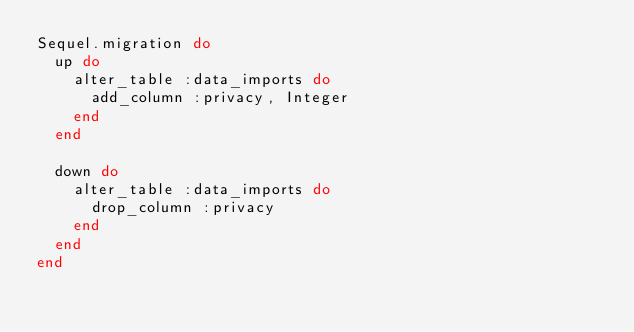Convert code to text. <code><loc_0><loc_0><loc_500><loc_500><_Ruby_>Sequel.migration do
  up do
    alter_table :data_imports do
      add_column :privacy, Integer
    end
  end

  down do
    alter_table :data_imports do
      drop_column :privacy
    end
  end
end
</code> 